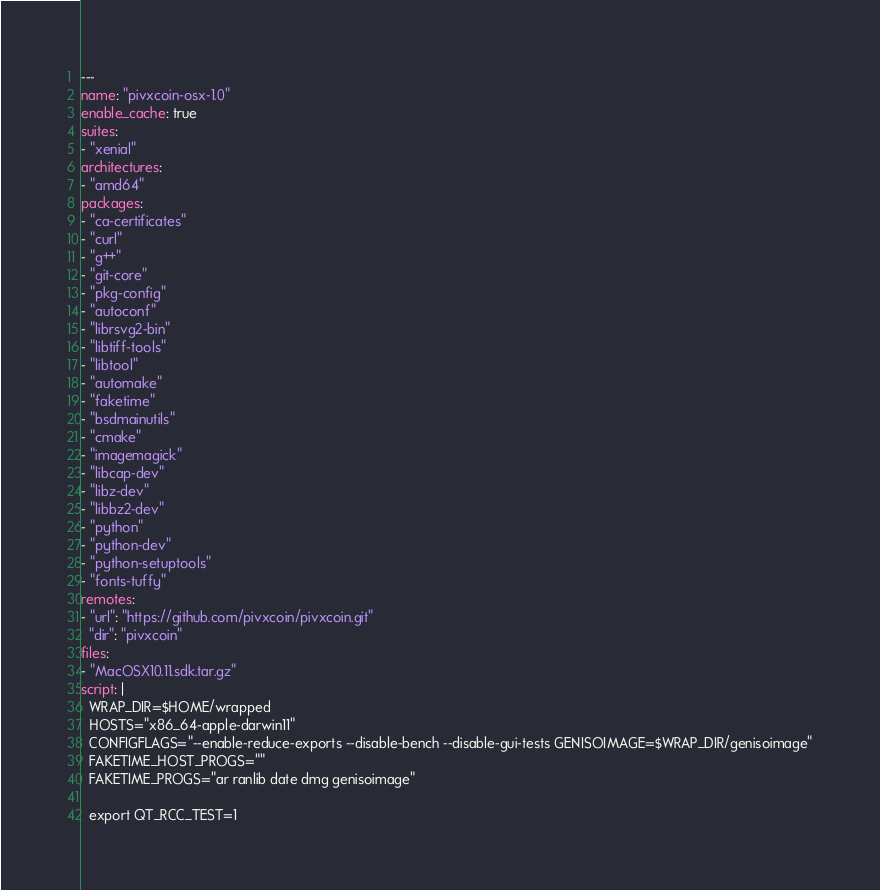Convert code to text. <code><loc_0><loc_0><loc_500><loc_500><_YAML_>---
name: "pivxcoin-osx-1.0"
enable_cache: true
suites:
- "xenial"
architectures:
- "amd64"
packages:
- "ca-certificates"
- "curl"
- "g++"
- "git-core"
- "pkg-config"
- "autoconf"
- "librsvg2-bin"
- "libtiff-tools"
- "libtool"
- "automake"
- "faketime"
- "bsdmainutils"
- "cmake"
- "imagemagick"
- "libcap-dev"
- "libz-dev"
- "libbz2-dev"
- "python"
- "python-dev"
- "python-setuptools"
- "fonts-tuffy"
remotes:
- "url": "https://github.com/pivxcoin/pivxcoin.git"
  "dir": "pivxcoin"
files:
- "MacOSX10.11.sdk.tar.gz"
script: |
  WRAP_DIR=$HOME/wrapped
  HOSTS="x86_64-apple-darwin11"
  CONFIGFLAGS="--enable-reduce-exports --disable-bench --disable-gui-tests GENISOIMAGE=$WRAP_DIR/genisoimage"
  FAKETIME_HOST_PROGS=""
  FAKETIME_PROGS="ar ranlib date dmg genisoimage"

  export QT_RCC_TEST=1</code> 